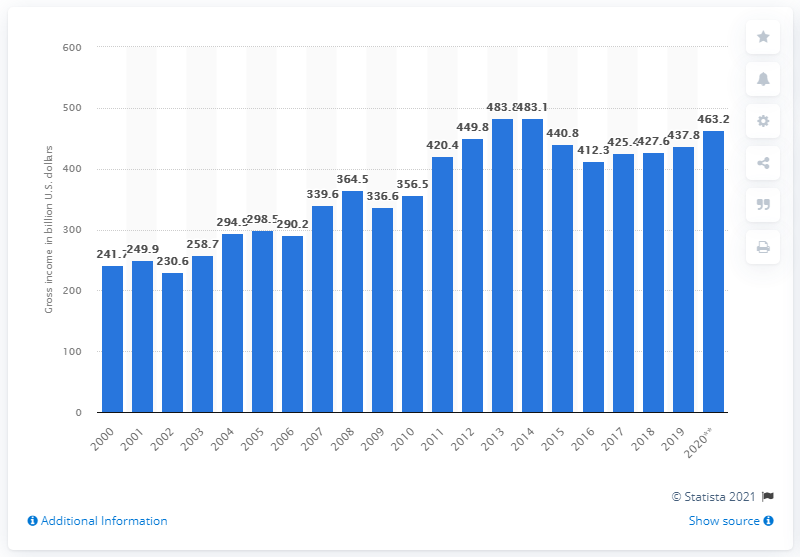Specify some key components in this picture. By the end of 2020, the gross farm income in the United States was approximately $463.2 billion. The gross farm income in the United States in 2001 was 249.9 billion dollars. 